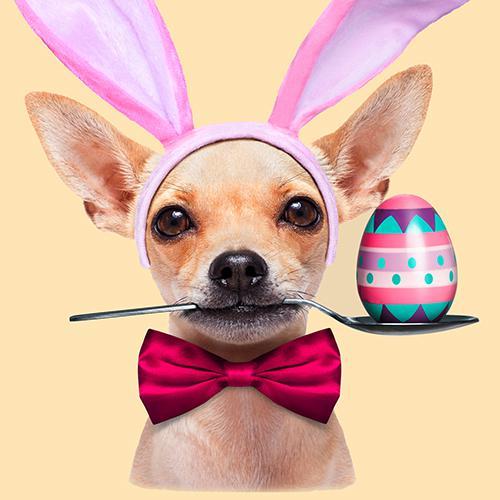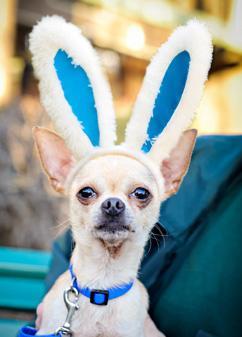The first image is the image on the left, the second image is the image on the right. Considering the images on both sides, is "The left image has a carrot." valid? Answer yes or no. No. The first image is the image on the left, the second image is the image on the right. Given the left and right images, does the statement "A dog has an orange carrot in an image that includes bunny ears." hold true? Answer yes or no. No. 